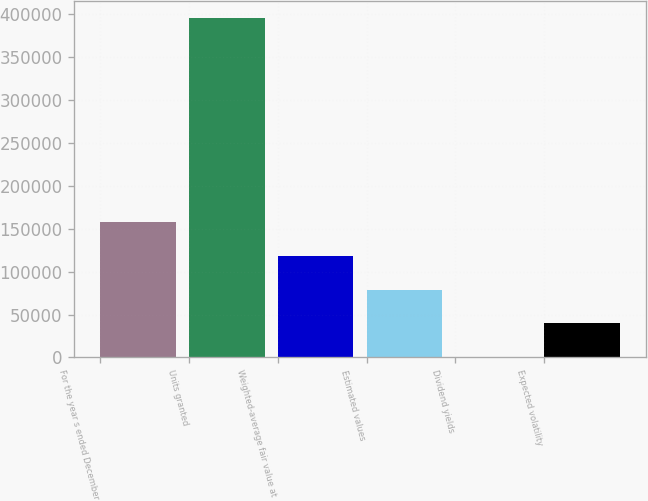<chart> <loc_0><loc_0><loc_500><loc_500><bar_chart><fcel>For the year s ended December<fcel>Units granted<fcel>Weighted-average fair value at<fcel>Estimated values<fcel>Dividend yields<fcel>Expected volatility<nl><fcel>158346<fcel>395862<fcel>118760<fcel>79174<fcel>2<fcel>39588<nl></chart> 